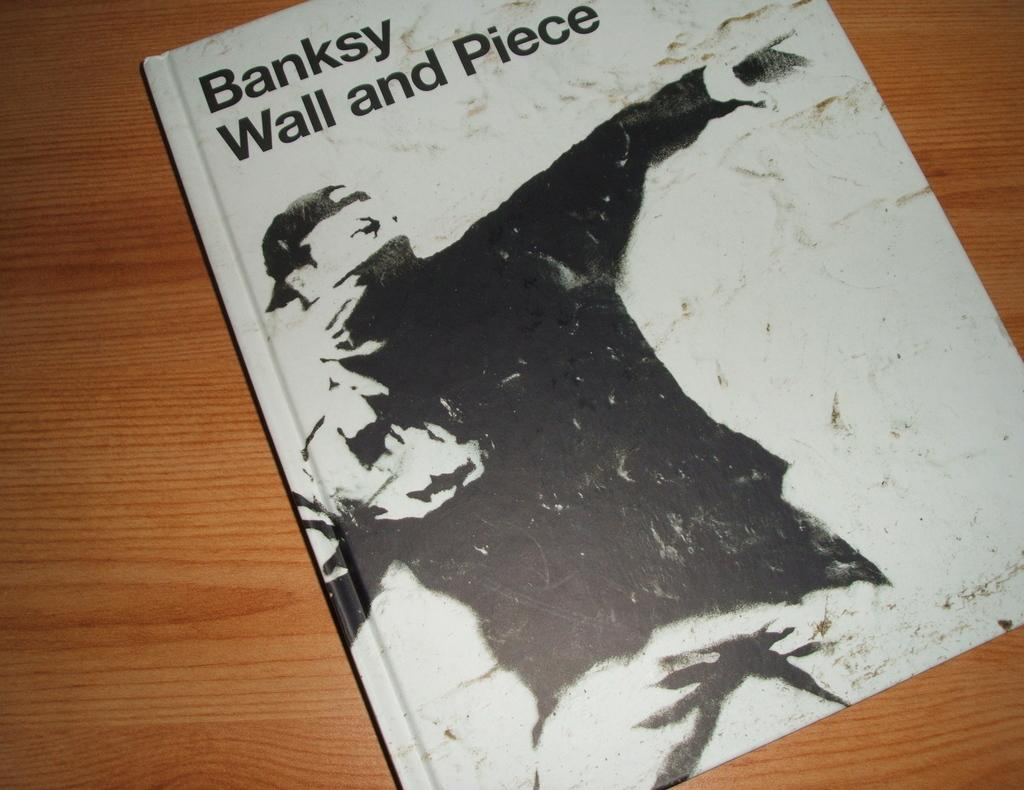Provide a one-sentence caption for the provided image. A BLACK AND WHITE BOOK CALLED BANKSY WALL AND PIECE. 